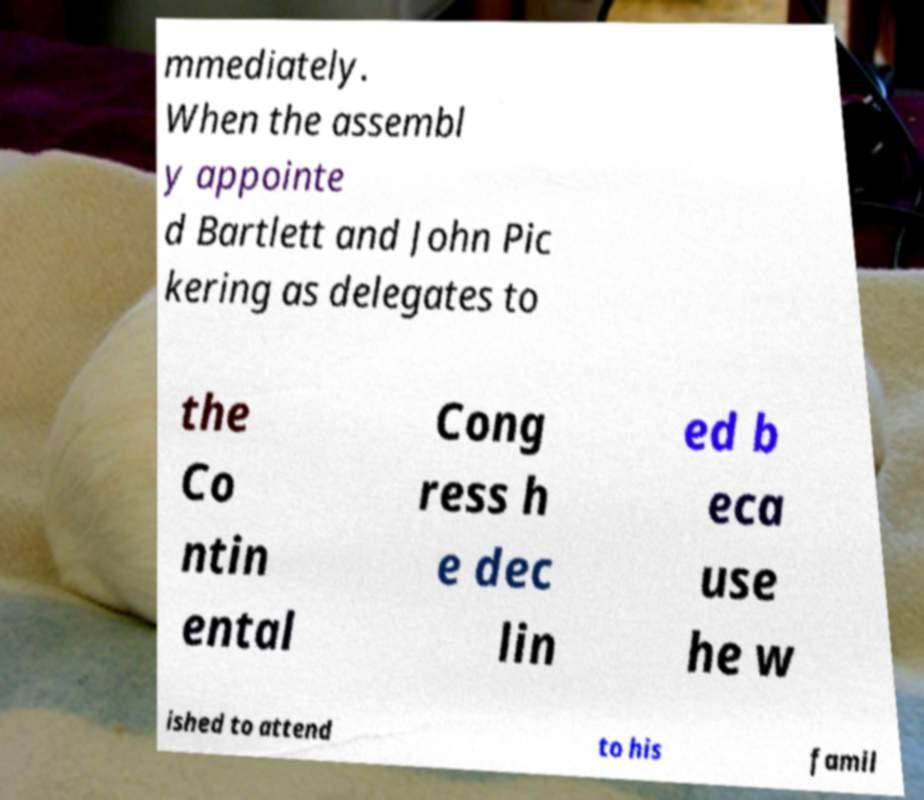Can you accurately transcribe the text from the provided image for me? mmediately. When the assembl y appointe d Bartlett and John Pic kering as delegates to the Co ntin ental Cong ress h e dec lin ed b eca use he w ished to attend to his famil 